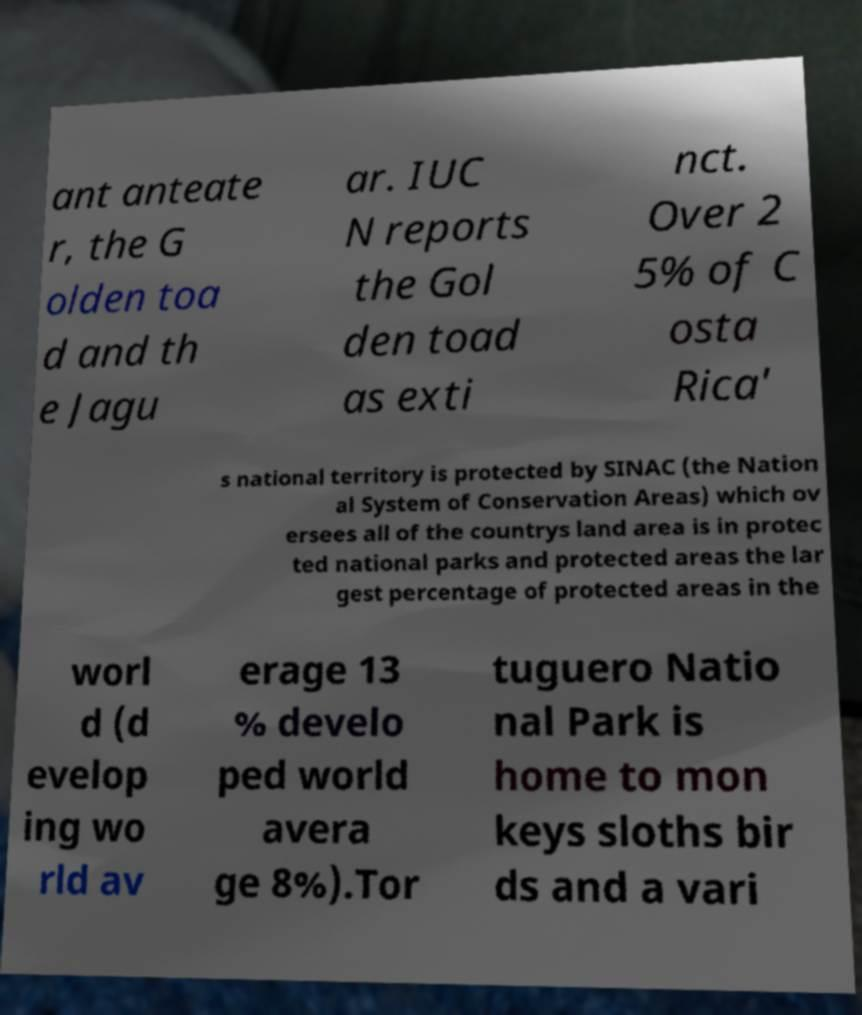Can you accurately transcribe the text from the provided image for me? ant anteate r, the G olden toa d and th e Jagu ar. IUC N reports the Gol den toad as exti nct. Over 2 5% of C osta Rica' s national territory is protected by SINAC (the Nation al System of Conservation Areas) which ov ersees all of the countrys land area is in protec ted national parks and protected areas the lar gest percentage of protected areas in the worl d (d evelop ing wo rld av erage 13 % develo ped world avera ge 8%).Tor tuguero Natio nal Park is home to mon keys sloths bir ds and a vari 